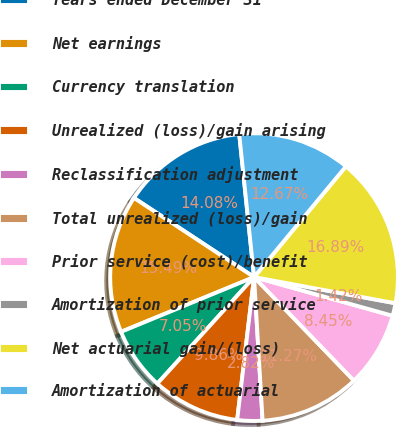<chart> <loc_0><loc_0><loc_500><loc_500><pie_chart><fcel>Years ended December 31<fcel>Net earnings<fcel>Currency translation<fcel>Unrealized (loss)/gain arising<fcel>Reclassification adjustment<fcel>Total unrealized (loss)/gain<fcel>Prior service (cost)/benefit<fcel>Amortization of prior service<fcel>Net actuarial gain/(loss)<fcel>Amortization of actuarial<nl><fcel>14.08%<fcel>15.49%<fcel>7.05%<fcel>9.86%<fcel>2.82%<fcel>11.27%<fcel>8.45%<fcel>1.42%<fcel>16.89%<fcel>12.67%<nl></chart> 